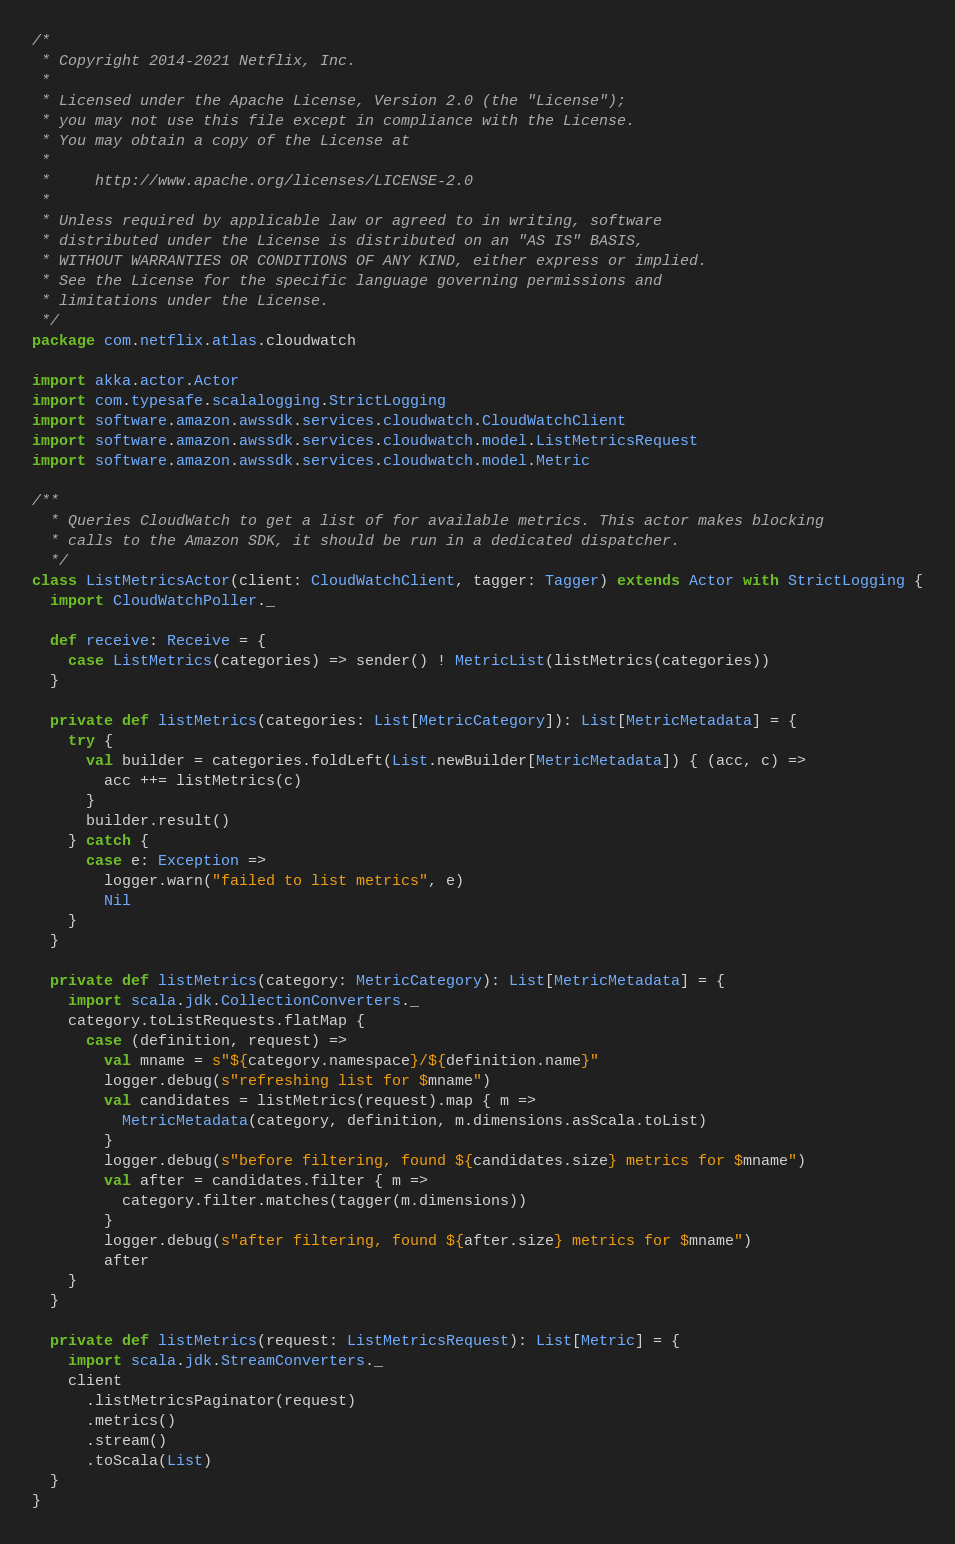Convert code to text. <code><loc_0><loc_0><loc_500><loc_500><_Scala_>/*
 * Copyright 2014-2021 Netflix, Inc.
 *
 * Licensed under the Apache License, Version 2.0 (the "License");
 * you may not use this file except in compliance with the License.
 * You may obtain a copy of the License at
 *
 *     http://www.apache.org/licenses/LICENSE-2.0
 *
 * Unless required by applicable law or agreed to in writing, software
 * distributed under the License is distributed on an "AS IS" BASIS,
 * WITHOUT WARRANTIES OR CONDITIONS OF ANY KIND, either express or implied.
 * See the License for the specific language governing permissions and
 * limitations under the License.
 */
package com.netflix.atlas.cloudwatch

import akka.actor.Actor
import com.typesafe.scalalogging.StrictLogging
import software.amazon.awssdk.services.cloudwatch.CloudWatchClient
import software.amazon.awssdk.services.cloudwatch.model.ListMetricsRequest
import software.amazon.awssdk.services.cloudwatch.model.Metric

/**
  * Queries CloudWatch to get a list of for available metrics. This actor makes blocking
  * calls to the Amazon SDK, it should be run in a dedicated dispatcher.
  */
class ListMetricsActor(client: CloudWatchClient, tagger: Tagger) extends Actor with StrictLogging {
  import CloudWatchPoller._

  def receive: Receive = {
    case ListMetrics(categories) => sender() ! MetricList(listMetrics(categories))
  }

  private def listMetrics(categories: List[MetricCategory]): List[MetricMetadata] = {
    try {
      val builder = categories.foldLeft(List.newBuilder[MetricMetadata]) { (acc, c) =>
        acc ++= listMetrics(c)
      }
      builder.result()
    } catch {
      case e: Exception =>
        logger.warn("failed to list metrics", e)
        Nil
    }
  }

  private def listMetrics(category: MetricCategory): List[MetricMetadata] = {
    import scala.jdk.CollectionConverters._
    category.toListRequests.flatMap {
      case (definition, request) =>
        val mname = s"${category.namespace}/${definition.name}"
        logger.debug(s"refreshing list for $mname")
        val candidates = listMetrics(request).map { m =>
          MetricMetadata(category, definition, m.dimensions.asScala.toList)
        }
        logger.debug(s"before filtering, found ${candidates.size} metrics for $mname")
        val after = candidates.filter { m =>
          category.filter.matches(tagger(m.dimensions))
        }
        logger.debug(s"after filtering, found ${after.size} metrics for $mname")
        after
    }
  }

  private def listMetrics(request: ListMetricsRequest): List[Metric] = {
    import scala.jdk.StreamConverters._
    client
      .listMetricsPaginator(request)
      .metrics()
      .stream()
      .toScala(List)
  }
}
</code> 